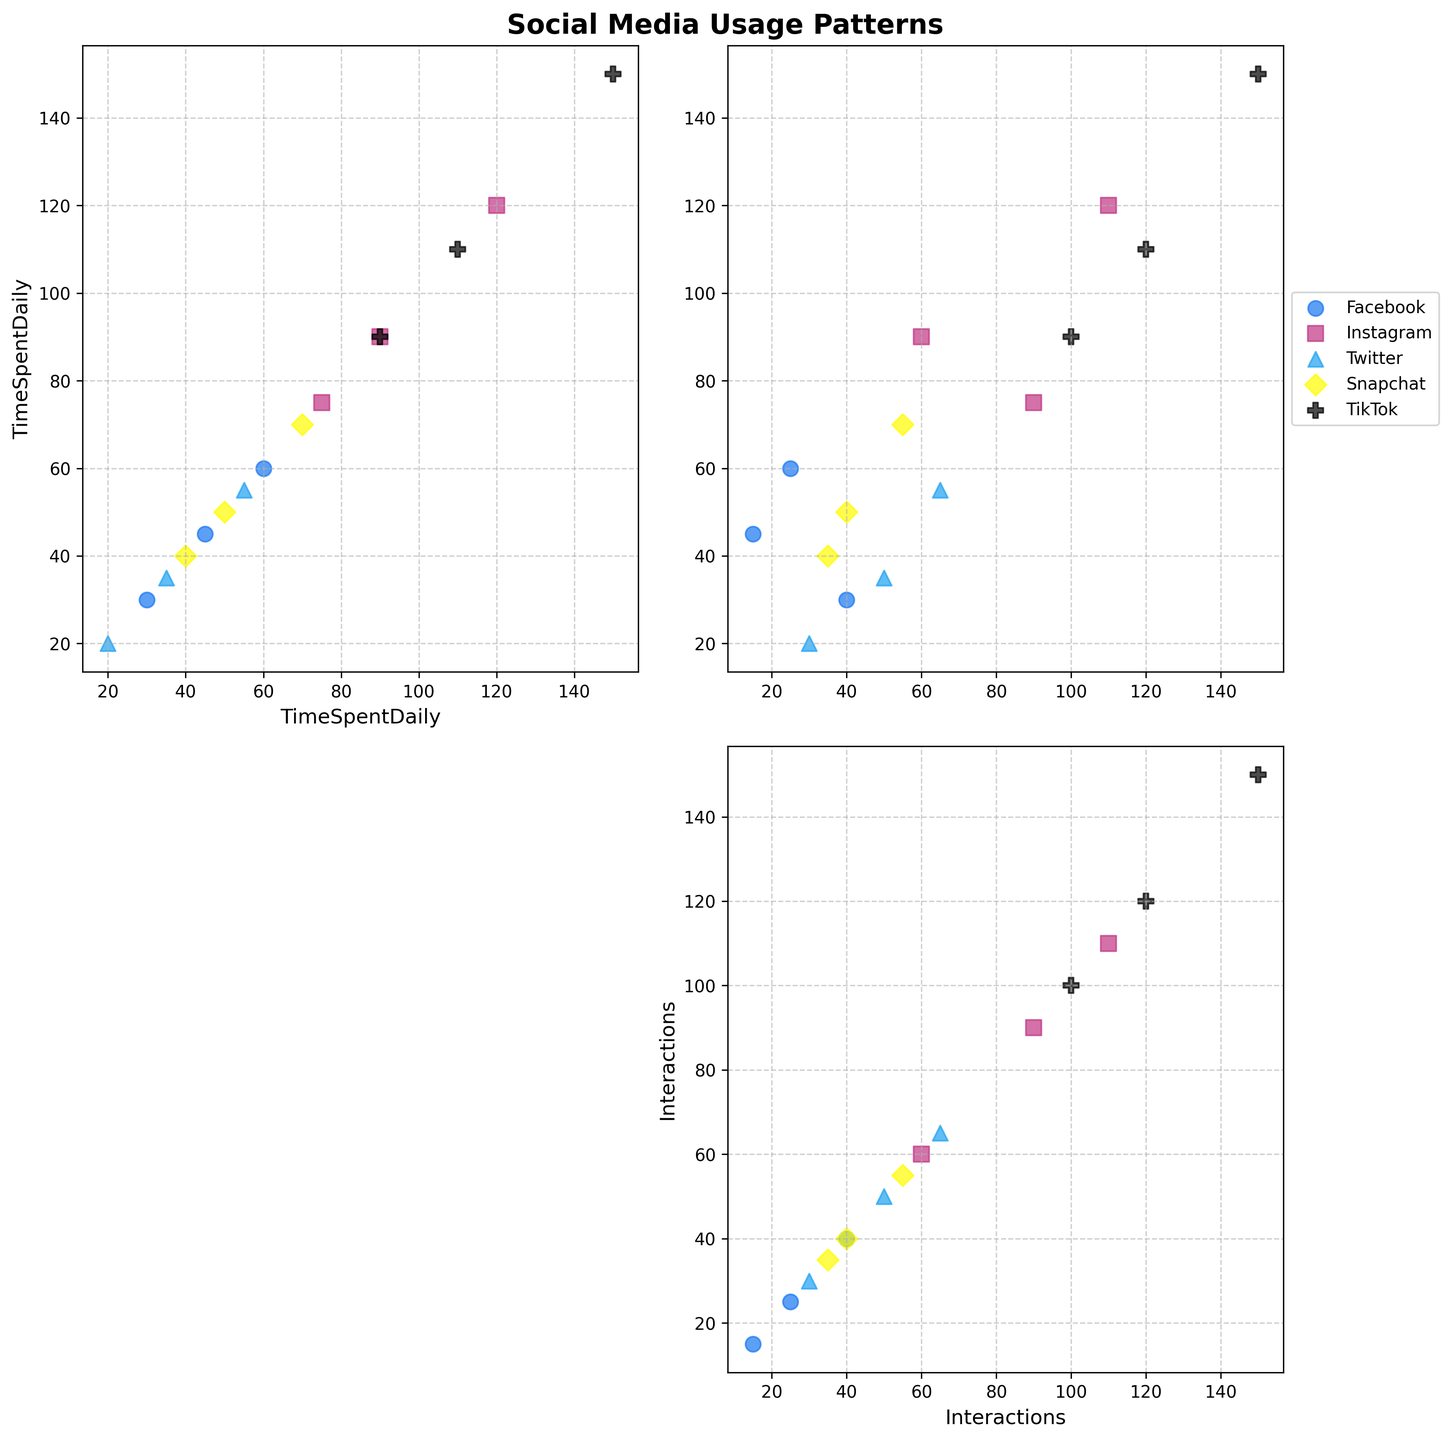What is the title of the figure? The title of the figure is usually placed at the top and is the first text you see. In this case, it says "Social Media Usage Patterns."
Answer: Social Media Usage Patterns What are the two variables plotted in the scatter plot matrix? The axes in each subplot represent the two variables. The names "Time Spent Daily" and "Interactions" appear repeatedly on the x and y axes.
Answer: Time Spent Daily and Interactions How many different platforms are represented in the plot? By looking at the legend in the top-right subplot, we see five different colored markers: one for each platform.
Answer: 5 Which platform shows the highest Time Spent Daily? Find the subplot where "Time Spent Daily" is on the y-axis. TikTok has the highest data point at 150 minutes.
Answer: TikTok What color represents Snapchat in the scatter plot? The legend indicates that Snapchat is represented by a yellow color.
Answer: Yellow Which platform has the highest number of interactions? By examining the subplots where "Interactions" is on the y-axis and finding the highest value, TikTok shows data points up to 150 interactions.
Answer: TikTok Which two platforms show overlapping data points in terms of Time Spent Daily and Interactions? Examine each subplot carefully where data points from different platforms overlap in both "Time Spent Daily" and "Interactions." Facebook and Twitter have overlapping data points.
Answer: Facebook and Twitter Is there any platform where Time Spent Daily and Interactions seem directly proportional? By visually examining the trend of data points on the subplots, TikTok shows a strong linear relationship between "Time Spent Daily" and "Interactions."
Answer: TikTok Which platform uses a square marker in the scatter plot? The legend shows that Instagram uses a square marker. Look for square markers in the subplots to confirm.
Answer: Instagram Which platform has the widest range in Time Spent Daily? Compare the range (difference between maximum and minimum value) in "Time Spent Daily" for each platform in the respective subplots. TikTok ranges from 90 to 150 minutes.
Answer: TikTok 